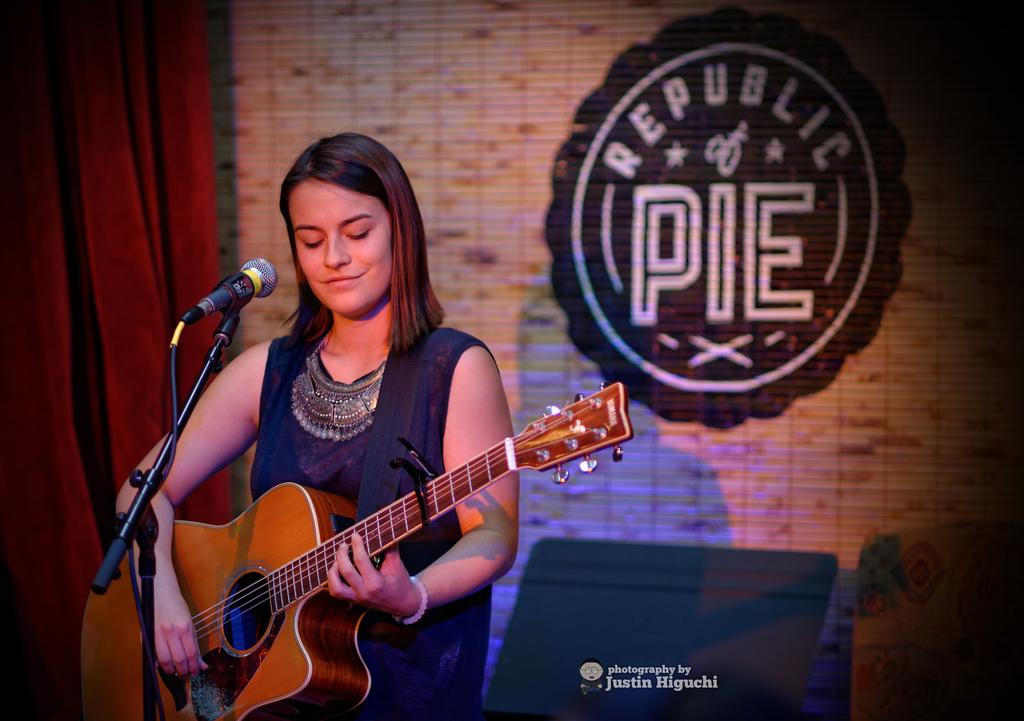What color is the curtain in the image? The curtain in the image is red. What is the woman in the image holding? The woman is holding a guitar in the image. What object is in front of the woman? There is a microphone in front of the woman. Is there a table in the image? No, there is no table present in the image. Can you see a stove in the image? No, there is no stove present in the image. 